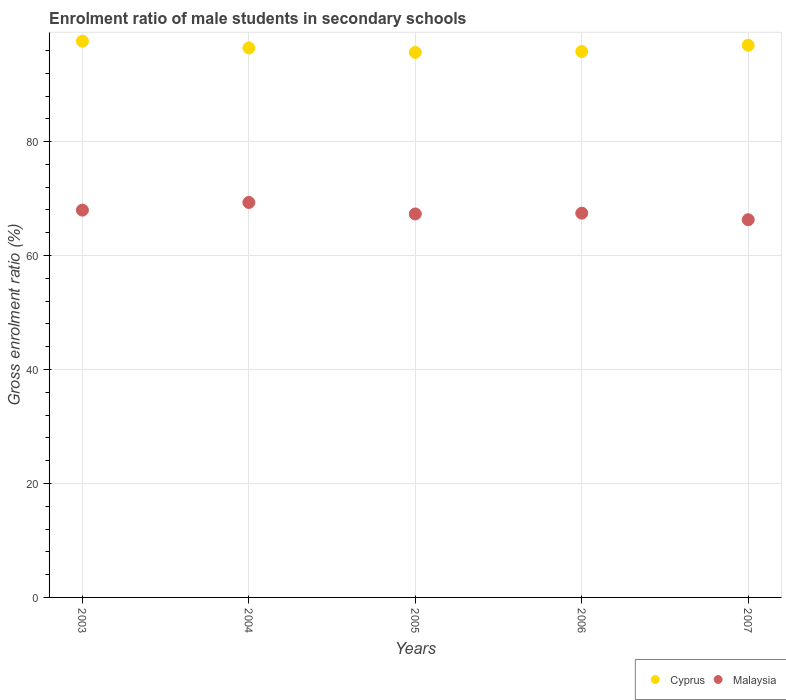How many different coloured dotlines are there?
Provide a short and direct response. 2. Is the number of dotlines equal to the number of legend labels?
Give a very brief answer. Yes. What is the enrolment ratio of male students in secondary schools in Cyprus in 2003?
Give a very brief answer. 97.62. Across all years, what is the maximum enrolment ratio of male students in secondary schools in Malaysia?
Make the answer very short. 69.32. Across all years, what is the minimum enrolment ratio of male students in secondary schools in Malaysia?
Give a very brief answer. 66.29. In which year was the enrolment ratio of male students in secondary schools in Cyprus minimum?
Provide a short and direct response. 2005. What is the total enrolment ratio of male students in secondary schools in Malaysia in the graph?
Give a very brief answer. 338.31. What is the difference between the enrolment ratio of male students in secondary schools in Malaysia in 2003 and that in 2006?
Keep it short and to the point. 0.53. What is the difference between the enrolment ratio of male students in secondary schools in Malaysia in 2006 and the enrolment ratio of male students in secondary schools in Cyprus in 2007?
Make the answer very short. -29.47. What is the average enrolment ratio of male students in secondary schools in Cyprus per year?
Ensure brevity in your answer.  96.48. In the year 2006, what is the difference between the enrolment ratio of male students in secondary schools in Malaysia and enrolment ratio of male students in secondary schools in Cyprus?
Your response must be concise. -28.36. In how many years, is the enrolment ratio of male students in secondary schools in Cyprus greater than 4 %?
Make the answer very short. 5. What is the ratio of the enrolment ratio of male students in secondary schools in Cyprus in 2004 to that in 2005?
Provide a short and direct response. 1.01. Is the enrolment ratio of male students in secondary schools in Cyprus in 2004 less than that in 2005?
Provide a succinct answer. No. Is the difference between the enrolment ratio of male students in secondary schools in Malaysia in 2004 and 2007 greater than the difference between the enrolment ratio of male students in secondary schools in Cyprus in 2004 and 2007?
Ensure brevity in your answer.  Yes. What is the difference between the highest and the second highest enrolment ratio of male students in secondary schools in Cyprus?
Offer a terse response. 0.72. What is the difference between the highest and the lowest enrolment ratio of male students in secondary schools in Malaysia?
Offer a very short reply. 3.03. Does the enrolment ratio of male students in secondary schools in Cyprus monotonically increase over the years?
Your answer should be very brief. No. Is the enrolment ratio of male students in secondary schools in Malaysia strictly less than the enrolment ratio of male students in secondary schools in Cyprus over the years?
Give a very brief answer. Yes. How many dotlines are there?
Give a very brief answer. 2. What is the difference between two consecutive major ticks on the Y-axis?
Keep it short and to the point. 20. Does the graph contain any zero values?
Your answer should be very brief. No. How many legend labels are there?
Your answer should be very brief. 2. How are the legend labels stacked?
Provide a short and direct response. Horizontal. What is the title of the graph?
Make the answer very short. Enrolment ratio of male students in secondary schools. Does "Colombia" appear as one of the legend labels in the graph?
Offer a very short reply. No. What is the Gross enrolment ratio (%) of Cyprus in 2003?
Offer a very short reply. 97.62. What is the Gross enrolment ratio (%) in Malaysia in 2003?
Provide a succinct answer. 67.97. What is the Gross enrolment ratio (%) of Cyprus in 2004?
Give a very brief answer. 96.43. What is the Gross enrolment ratio (%) of Malaysia in 2004?
Ensure brevity in your answer.  69.32. What is the Gross enrolment ratio (%) in Cyprus in 2005?
Your response must be concise. 95.65. What is the Gross enrolment ratio (%) in Malaysia in 2005?
Your response must be concise. 67.3. What is the Gross enrolment ratio (%) of Cyprus in 2006?
Your answer should be very brief. 95.8. What is the Gross enrolment ratio (%) of Malaysia in 2006?
Your answer should be compact. 67.44. What is the Gross enrolment ratio (%) of Cyprus in 2007?
Your answer should be very brief. 96.91. What is the Gross enrolment ratio (%) in Malaysia in 2007?
Ensure brevity in your answer.  66.29. Across all years, what is the maximum Gross enrolment ratio (%) in Cyprus?
Keep it short and to the point. 97.62. Across all years, what is the maximum Gross enrolment ratio (%) in Malaysia?
Ensure brevity in your answer.  69.32. Across all years, what is the minimum Gross enrolment ratio (%) in Cyprus?
Make the answer very short. 95.65. Across all years, what is the minimum Gross enrolment ratio (%) of Malaysia?
Your answer should be very brief. 66.29. What is the total Gross enrolment ratio (%) of Cyprus in the graph?
Ensure brevity in your answer.  482.42. What is the total Gross enrolment ratio (%) in Malaysia in the graph?
Offer a very short reply. 338.31. What is the difference between the Gross enrolment ratio (%) in Cyprus in 2003 and that in 2004?
Provide a short and direct response. 1.19. What is the difference between the Gross enrolment ratio (%) of Malaysia in 2003 and that in 2004?
Provide a short and direct response. -1.35. What is the difference between the Gross enrolment ratio (%) in Cyprus in 2003 and that in 2005?
Your answer should be compact. 1.97. What is the difference between the Gross enrolment ratio (%) in Malaysia in 2003 and that in 2005?
Provide a succinct answer. 0.67. What is the difference between the Gross enrolment ratio (%) in Cyprus in 2003 and that in 2006?
Offer a terse response. 1.82. What is the difference between the Gross enrolment ratio (%) of Malaysia in 2003 and that in 2006?
Your answer should be very brief. 0.53. What is the difference between the Gross enrolment ratio (%) of Cyprus in 2003 and that in 2007?
Keep it short and to the point. 0.72. What is the difference between the Gross enrolment ratio (%) in Malaysia in 2003 and that in 2007?
Offer a terse response. 1.68. What is the difference between the Gross enrolment ratio (%) in Cyprus in 2004 and that in 2005?
Provide a short and direct response. 0.78. What is the difference between the Gross enrolment ratio (%) in Malaysia in 2004 and that in 2005?
Make the answer very short. 2.02. What is the difference between the Gross enrolment ratio (%) of Cyprus in 2004 and that in 2006?
Give a very brief answer. 0.63. What is the difference between the Gross enrolment ratio (%) in Malaysia in 2004 and that in 2006?
Provide a succinct answer. 1.88. What is the difference between the Gross enrolment ratio (%) of Cyprus in 2004 and that in 2007?
Ensure brevity in your answer.  -0.48. What is the difference between the Gross enrolment ratio (%) in Malaysia in 2004 and that in 2007?
Offer a terse response. 3.03. What is the difference between the Gross enrolment ratio (%) of Cyprus in 2005 and that in 2006?
Your answer should be compact. -0.15. What is the difference between the Gross enrolment ratio (%) in Malaysia in 2005 and that in 2006?
Your response must be concise. -0.14. What is the difference between the Gross enrolment ratio (%) of Cyprus in 2005 and that in 2007?
Provide a short and direct response. -1.25. What is the difference between the Gross enrolment ratio (%) of Malaysia in 2005 and that in 2007?
Provide a succinct answer. 1.01. What is the difference between the Gross enrolment ratio (%) in Cyprus in 2006 and that in 2007?
Offer a very short reply. -1.1. What is the difference between the Gross enrolment ratio (%) of Malaysia in 2006 and that in 2007?
Your answer should be very brief. 1.15. What is the difference between the Gross enrolment ratio (%) of Cyprus in 2003 and the Gross enrolment ratio (%) of Malaysia in 2004?
Provide a succinct answer. 28.31. What is the difference between the Gross enrolment ratio (%) in Cyprus in 2003 and the Gross enrolment ratio (%) in Malaysia in 2005?
Give a very brief answer. 30.32. What is the difference between the Gross enrolment ratio (%) of Cyprus in 2003 and the Gross enrolment ratio (%) of Malaysia in 2006?
Keep it short and to the point. 30.18. What is the difference between the Gross enrolment ratio (%) of Cyprus in 2003 and the Gross enrolment ratio (%) of Malaysia in 2007?
Give a very brief answer. 31.33. What is the difference between the Gross enrolment ratio (%) of Cyprus in 2004 and the Gross enrolment ratio (%) of Malaysia in 2005?
Make the answer very short. 29.13. What is the difference between the Gross enrolment ratio (%) in Cyprus in 2004 and the Gross enrolment ratio (%) in Malaysia in 2006?
Ensure brevity in your answer.  28.99. What is the difference between the Gross enrolment ratio (%) in Cyprus in 2004 and the Gross enrolment ratio (%) in Malaysia in 2007?
Make the answer very short. 30.14. What is the difference between the Gross enrolment ratio (%) of Cyprus in 2005 and the Gross enrolment ratio (%) of Malaysia in 2006?
Your response must be concise. 28.22. What is the difference between the Gross enrolment ratio (%) of Cyprus in 2005 and the Gross enrolment ratio (%) of Malaysia in 2007?
Offer a very short reply. 29.37. What is the difference between the Gross enrolment ratio (%) of Cyprus in 2006 and the Gross enrolment ratio (%) of Malaysia in 2007?
Make the answer very short. 29.51. What is the average Gross enrolment ratio (%) in Cyprus per year?
Offer a terse response. 96.48. What is the average Gross enrolment ratio (%) of Malaysia per year?
Give a very brief answer. 67.66. In the year 2003, what is the difference between the Gross enrolment ratio (%) in Cyprus and Gross enrolment ratio (%) in Malaysia?
Offer a very short reply. 29.65. In the year 2004, what is the difference between the Gross enrolment ratio (%) of Cyprus and Gross enrolment ratio (%) of Malaysia?
Your answer should be compact. 27.11. In the year 2005, what is the difference between the Gross enrolment ratio (%) in Cyprus and Gross enrolment ratio (%) in Malaysia?
Offer a very short reply. 28.36. In the year 2006, what is the difference between the Gross enrolment ratio (%) of Cyprus and Gross enrolment ratio (%) of Malaysia?
Your response must be concise. 28.36. In the year 2007, what is the difference between the Gross enrolment ratio (%) in Cyprus and Gross enrolment ratio (%) in Malaysia?
Offer a terse response. 30.62. What is the ratio of the Gross enrolment ratio (%) of Cyprus in 2003 to that in 2004?
Give a very brief answer. 1.01. What is the ratio of the Gross enrolment ratio (%) of Malaysia in 2003 to that in 2004?
Ensure brevity in your answer.  0.98. What is the ratio of the Gross enrolment ratio (%) in Cyprus in 2003 to that in 2005?
Provide a succinct answer. 1.02. What is the ratio of the Gross enrolment ratio (%) of Malaysia in 2003 to that in 2005?
Your answer should be compact. 1.01. What is the ratio of the Gross enrolment ratio (%) of Malaysia in 2003 to that in 2006?
Give a very brief answer. 1.01. What is the ratio of the Gross enrolment ratio (%) of Cyprus in 2003 to that in 2007?
Ensure brevity in your answer.  1.01. What is the ratio of the Gross enrolment ratio (%) of Malaysia in 2003 to that in 2007?
Your answer should be compact. 1.03. What is the ratio of the Gross enrolment ratio (%) of Cyprus in 2004 to that in 2005?
Provide a short and direct response. 1.01. What is the ratio of the Gross enrolment ratio (%) in Cyprus in 2004 to that in 2006?
Your answer should be very brief. 1.01. What is the ratio of the Gross enrolment ratio (%) of Malaysia in 2004 to that in 2006?
Provide a short and direct response. 1.03. What is the ratio of the Gross enrolment ratio (%) of Malaysia in 2004 to that in 2007?
Provide a short and direct response. 1.05. What is the ratio of the Gross enrolment ratio (%) in Cyprus in 2005 to that in 2006?
Your answer should be very brief. 1. What is the ratio of the Gross enrolment ratio (%) in Cyprus in 2005 to that in 2007?
Offer a very short reply. 0.99. What is the ratio of the Gross enrolment ratio (%) of Malaysia in 2005 to that in 2007?
Provide a succinct answer. 1.02. What is the ratio of the Gross enrolment ratio (%) of Cyprus in 2006 to that in 2007?
Your answer should be very brief. 0.99. What is the ratio of the Gross enrolment ratio (%) of Malaysia in 2006 to that in 2007?
Give a very brief answer. 1.02. What is the difference between the highest and the second highest Gross enrolment ratio (%) of Cyprus?
Provide a short and direct response. 0.72. What is the difference between the highest and the second highest Gross enrolment ratio (%) in Malaysia?
Keep it short and to the point. 1.35. What is the difference between the highest and the lowest Gross enrolment ratio (%) in Cyprus?
Provide a succinct answer. 1.97. What is the difference between the highest and the lowest Gross enrolment ratio (%) of Malaysia?
Ensure brevity in your answer.  3.03. 